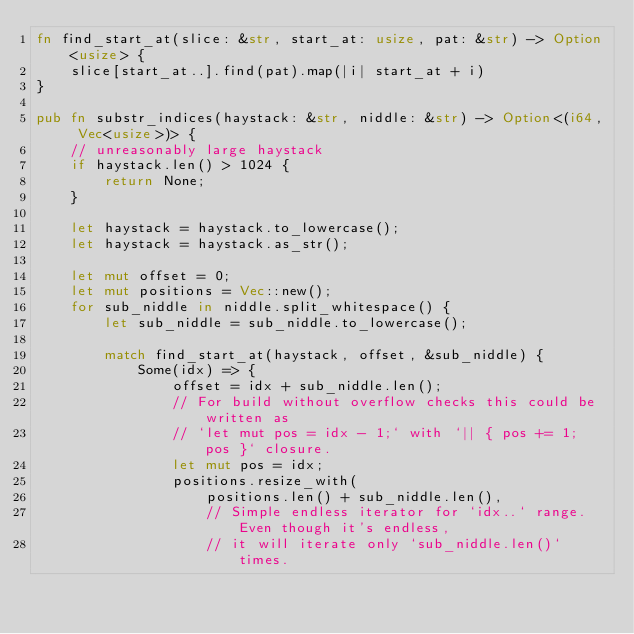Convert code to text. <code><loc_0><loc_0><loc_500><loc_500><_Rust_>fn find_start_at(slice: &str, start_at: usize, pat: &str) -> Option<usize> {
    slice[start_at..].find(pat).map(|i| start_at + i)
}

pub fn substr_indices(haystack: &str, niddle: &str) -> Option<(i64, Vec<usize>)> {
    // unreasonably large haystack
    if haystack.len() > 1024 {
        return None;
    }

    let haystack = haystack.to_lowercase();
    let haystack = haystack.as_str();

    let mut offset = 0;
    let mut positions = Vec::new();
    for sub_niddle in niddle.split_whitespace() {
        let sub_niddle = sub_niddle.to_lowercase();

        match find_start_at(haystack, offset, &sub_niddle) {
            Some(idx) => {
                offset = idx + sub_niddle.len();
                // For build without overflow checks this could be written as
                // `let mut pos = idx - 1;` with `|| { pos += 1; pos }` closure.
                let mut pos = idx;
                positions.resize_with(
                    positions.len() + sub_niddle.len(),
                    // Simple endless iterator for `idx..` range. Even though it's endless,
                    // it will iterate only `sub_niddle.len()` times.</code> 